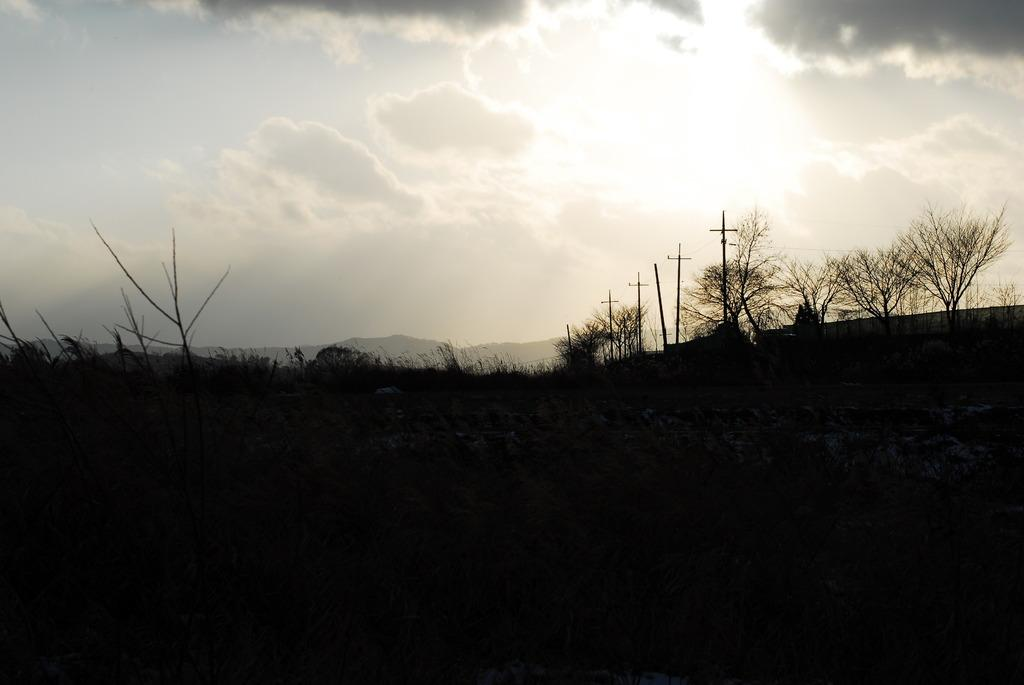What type of vegetation can be seen in the image? There are plants and trees in the image. What structures are present in the image? There are poles and a fence in the image. What can be seen in the background of the image? Hills and the sky are visible in the background of the image. Where is the parcel located in the image? There is no parcel present in the image. What type of bulb is used to light up the town in the image? There is no town or bulb present in the image. 